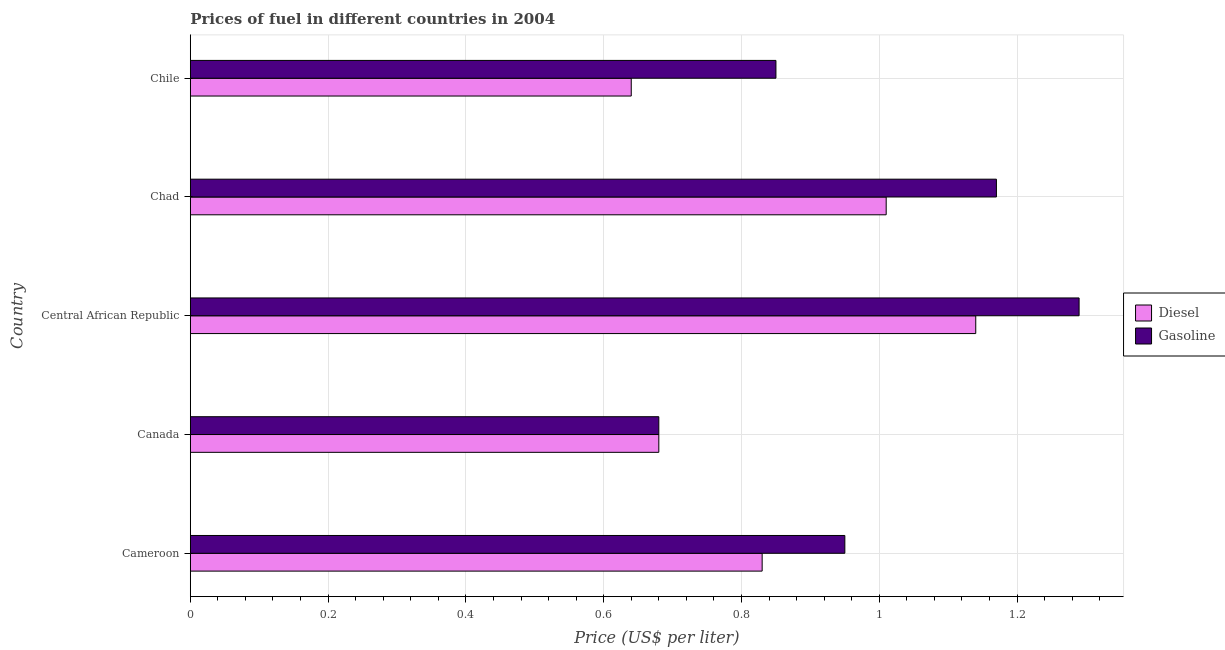How many different coloured bars are there?
Ensure brevity in your answer.  2. Are the number of bars on each tick of the Y-axis equal?
Your response must be concise. Yes. How many bars are there on the 4th tick from the top?
Provide a succinct answer. 2. How many bars are there on the 5th tick from the bottom?
Give a very brief answer. 2. What is the label of the 2nd group of bars from the top?
Ensure brevity in your answer.  Chad. In how many cases, is the number of bars for a given country not equal to the number of legend labels?
Keep it short and to the point. 0. What is the diesel price in Central African Republic?
Your answer should be compact. 1.14. Across all countries, what is the maximum gasoline price?
Give a very brief answer. 1.29. Across all countries, what is the minimum diesel price?
Your response must be concise. 0.64. In which country was the gasoline price maximum?
Make the answer very short. Central African Republic. In which country was the diesel price minimum?
Your answer should be very brief. Chile. What is the total gasoline price in the graph?
Offer a terse response. 4.94. What is the difference between the diesel price in Cameroon and the gasoline price in Canada?
Give a very brief answer. 0.15. What is the difference between the gasoline price and diesel price in Cameroon?
Keep it short and to the point. 0.12. In how many countries, is the diesel price greater than 0.48000000000000004 US$ per litre?
Your answer should be very brief. 5. What is the ratio of the gasoline price in Cameroon to that in Central African Republic?
Provide a succinct answer. 0.74. Is the gasoline price in Cameroon less than that in Central African Republic?
Provide a succinct answer. Yes. What is the difference between the highest and the second highest gasoline price?
Ensure brevity in your answer.  0.12. What is the difference between the highest and the lowest gasoline price?
Give a very brief answer. 0.61. What does the 2nd bar from the top in Central African Republic represents?
Your response must be concise. Diesel. What does the 1st bar from the bottom in Canada represents?
Your answer should be very brief. Diesel. How many bars are there?
Provide a short and direct response. 10. Are all the bars in the graph horizontal?
Give a very brief answer. Yes. How many countries are there in the graph?
Offer a terse response. 5. Does the graph contain grids?
Your answer should be compact. Yes. How many legend labels are there?
Keep it short and to the point. 2. What is the title of the graph?
Offer a terse response. Prices of fuel in different countries in 2004. Does "% of gross capital formation" appear as one of the legend labels in the graph?
Offer a very short reply. No. What is the label or title of the X-axis?
Your answer should be compact. Price (US$ per liter). What is the label or title of the Y-axis?
Give a very brief answer. Country. What is the Price (US$ per liter) of Diesel in Cameroon?
Give a very brief answer. 0.83. What is the Price (US$ per liter) of Diesel in Canada?
Offer a very short reply. 0.68. What is the Price (US$ per liter) of Gasoline in Canada?
Keep it short and to the point. 0.68. What is the Price (US$ per liter) in Diesel in Central African Republic?
Provide a short and direct response. 1.14. What is the Price (US$ per liter) in Gasoline in Central African Republic?
Your response must be concise. 1.29. What is the Price (US$ per liter) in Diesel in Chad?
Offer a terse response. 1.01. What is the Price (US$ per liter) in Gasoline in Chad?
Provide a succinct answer. 1.17. What is the Price (US$ per liter) of Diesel in Chile?
Provide a short and direct response. 0.64. Across all countries, what is the maximum Price (US$ per liter) in Diesel?
Keep it short and to the point. 1.14. Across all countries, what is the maximum Price (US$ per liter) in Gasoline?
Your answer should be compact. 1.29. Across all countries, what is the minimum Price (US$ per liter) in Diesel?
Provide a short and direct response. 0.64. Across all countries, what is the minimum Price (US$ per liter) of Gasoline?
Your answer should be very brief. 0.68. What is the total Price (US$ per liter) of Diesel in the graph?
Your answer should be very brief. 4.3. What is the total Price (US$ per liter) in Gasoline in the graph?
Give a very brief answer. 4.94. What is the difference between the Price (US$ per liter) in Diesel in Cameroon and that in Canada?
Your response must be concise. 0.15. What is the difference between the Price (US$ per liter) of Gasoline in Cameroon and that in Canada?
Give a very brief answer. 0.27. What is the difference between the Price (US$ per liter) in Diesel in Cameroon and that in Central African Republic?
Make the answer very short. -0.31. What is the difference between the Price (US$ per liter) of Gasoline in Cameroon and that in Central African Republic?
Provide a succinct answer. -0.34. What is the difference between the Price (US$ per liter) of Diesel in Cameroon and that in Chad?
Make the answer very short. -0.18. What is the difference between the Price (US$ per liter) in Gasoline in Cameroon and that in Chad?
Provide a short and direct response. -0.22. What is the difference between the Price (US$ per liter) in Diesel in Cameroon and that in Chile?
Provide a succinct answer. 0.19. What is the difference between the Price (US$ per liter) in Diesel in Canada and that in Central African Republic?
Your answer should be very brief. -0.46. What is the difference between the Price (US$ per liter) of Gasoline in Canada and that in Central African Republic?
Provide a short and direct response. -0.61. What is the difference between the Price (US$ per liter) of Diesel in Canada and that in Chad?
Your answer should be compact. -0.33. What is the difference between the Price (US$ per liter) in Gasoline in Canada and that in Chad?
Your response must be concise. -0.49. What is the difference between the Price (US$ per liter) of Diesel in Canada and that in Chile?
Ensure brevity in your answer.  0.04. What is the difference between the Price (US$ per liter) in Gasoline in Canada and that in Chile?
Offer a very short reply. -0.17. What is the difference between the Price (US$ per liter) in Diesel in Central African Republic and that in Chad?
Provide a succinct answer. 0.13. What is the difference between the Price (US$ per liter) of Gasoline in Central African Republic and that in Chad?
Provide a succinct answer. 0.12. What is the difference between the Price (US$ per liter) in Gasoline in Central African Republic and that in Chile?
Keep it short and to the point. 0.44. What is the difference between the Price (US$ per liter) in Diesel in Chad and that in Chile?
Offer a very short reply. 0.37. What is the difference between the Price (US$ per liter) in Gasoline in Chad and that in Chile?
Offer a very short reply. 0.32. What is the difference between the Price (US$ per liter) in Diesel in Cameroon and the Price (US$ per liter) in Gasoline in Central African Republic?
Give a very brief answer. -0.46. What is the difference between the Price (US$ per liter) in Diesel in Cameroon and the Price (US$ per liter) in Gasoline in Chad?
Provide a succinct answer. -0.34. What is the difference between the Price (US$ per liter) in Diesel in Cameroon and the Price (US$ per liter) in Gasoline in Chile?
Your answer should be very brief. -0.02. What is the difference between the Price (US$ per liter) of Diesel in Canada and the Price (US$ per liter) of Gasoline in Central African Republic?
Your answer should be very brief. -0.61. What is the difference between the Price (US$ per liter) of Diesel in Canada and the Price (US$ per liter) of Gasoline in Chad?
Offer a terse response. -0.49. What is the difference between the Price (US$ per liter) in Diesel in Canada and the Price (US$ per liter) in Gasoline in Chile?
Give a very brief answer. -0.17. What is the difference between the Price (US$ per liter) in Diesel in Central African Republic and the Price (US$ per liter) in Gasoline in Chad?
Provide a succinct answer. -0.03. What is the difference between the Price (US$ per liter) of Diesel in Central African Republic and the Price (US$ per liter) of Gasoline in Chile?
Your answer should be very brief. 0.29. What is the difference between the Price (US$ per liter) of Diesel in Chad and the Price (US$ per liter) of Gasoline in Chile?
Provide a short and direct response. 0.16. What is the average Price (US$ per liter) in Diesel per country?
Keep it short and to the point. 0.86. What is the difference between the Price (US$ per liter) in Diesel and Price (US$ per liter) in Gasoline in Cameroon?
Provide a short and direct response. -0.12. What is the difference between the Price (US$ per liter) of Diesel and Price (US$ per liter) of Gasoline in Canada?
Make the answer very short. 0. What is the difference between the Price (US$ per liter) in Diesel and Price (US$ per liter) in Gasoline in Chad?
Your answer should be compact. -0.16. What is the difference between the Price (US$ per liter) of Diesel and Price (US$ per liter) of Gasoline in Chile?
Offer a very short reply. -0.21. What is the ratio of the Price (US$ per liter) in Diesel in Cameroon to that in Canada?
Make the answer very short. 1.22. What is the ratio of the Price (US$ per liter) in Gasoline in Cameroon to that in Canada?
Provide a succinct answer. 1.4. What is the ratio of the Price (US$ per liter) of Diesel in Cameroon to that in Central African Republic?
Offer a very short reply. 0.73. What is the ratio of the Price (US$ per liter) of Gasoline in Cameroon to that in Central African Republic?
Ensure brevity in your answer.  0.74. What is the ratio of the Price (US$ per liter) in Diesel in Cameroon to that in Chad?
Make the answer very short. 0.82. What is the ratio of the Price (US$ per liter) of Gasoline in Cameroon to that in Chad?
Offer a terse response. 0.81. What is the ratio of the Price (US$ per liter) of Diesel in Cameroon to that in Chile?
Your answer should be very brief. 1.3. What is the ratio of the Price (US$ per liter) of Gasoline in Cameroon to that in Chile?
Provide a short and direct response. 1.12. What is the ratio of the Price (US$ per liter) of Diesel in Canada to that in Central African Republic?
Keep it short and to the point. 0.6. What is the ratio of the Price (US$ per liter) of Gasoline in Canada to that in Central African Republic?
Your answer should be compact. 0.53. What is the ratio of the Price (US$ per liter) of Diesel in Canada to that in Chad?
Make the answer very short. 0.67. What is the ratio of the Price (US$ per liter) in Gasoline in Canada to that in Chad?
Keep it short and to the point. 0.58. What is the ratio of the Price (US$ per liter) in Diesel in Canada to that in Chile?
Ensure brevity in your answer.  1.06. What is the ratio of the Price (US$ per liter) in Gasoline in Canada to that in Chile?
Offer a terse response. 0.8. What is the ratio of the Price (US$ per liter) in Diesel in Central African Republic to that in Chad?
Your response must be concise. 1.13. What is the ratio of the Price (US$ per liter) in Gasoline in Central African Republic to that in Chad?
Your answer should be compact. 1.1. What is the ratio of the Price (US$ per liter) in Diesel in Central African Republic to that in Chile?
Offer a terse response. 1.78. What is the ratio of the Price (US$ per liter) in Gasoline in Central African Republic to that in Chile?
Your answer should be very brief. 1.52. What is the ratio of the Price (US$ per liter) of Diesel in Chad to that in Chile?
Your response must be concise. 1.58. What is the ratio of the Price (US$ per liter) of Gasoline in Chad to that in Chile?
Provide a succinct answer. 1.38. What is the difference between the highest and the second highest Price (US$ per liter) in Diesel?
Keep it short and to the point. 0.13. What is the difference between the highest and the second highest Price (US$ per liter) of Gasoline?
Provide a succinct answer. 0.12. What is the difference between the highest and the lowest Price (US$ per liter) of Diesel?
Offer a terse response. 0.5. What is the difference between the highest and the lowest Price (US$ per liter) of Gasoline?
Provide a succinct answer. 0.61. 